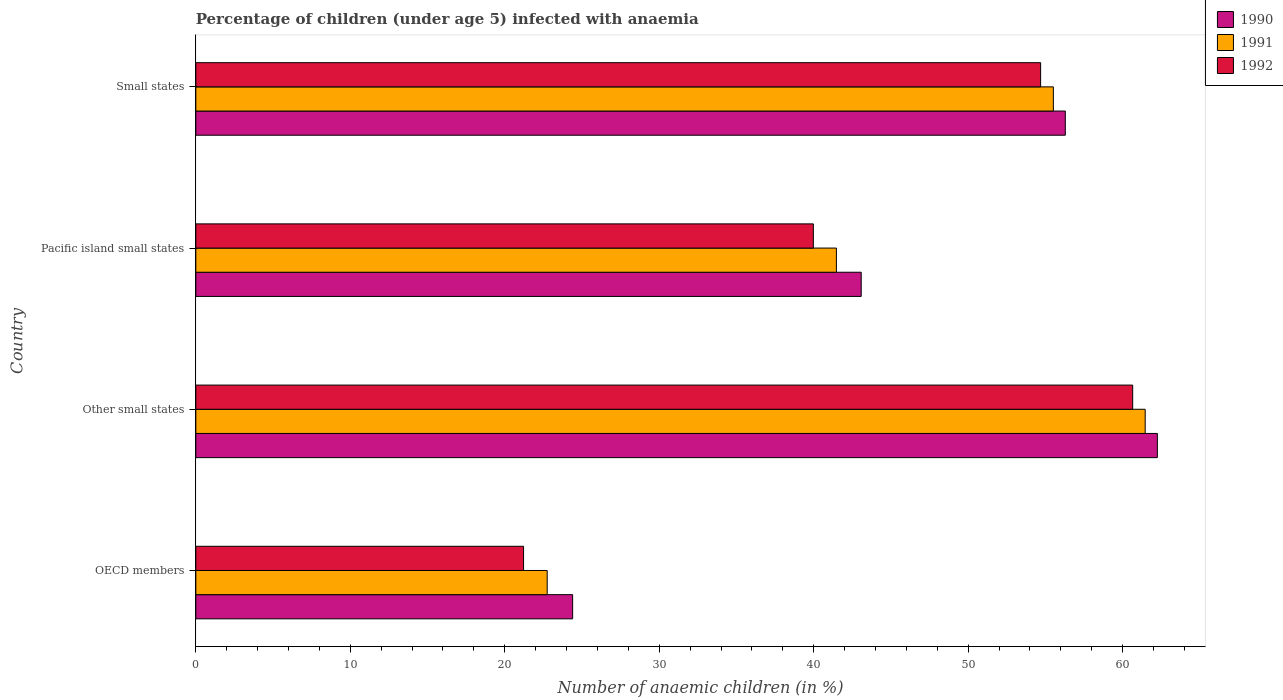How many different coloured bars are there?
Give a very brief answer. 3. Are the number of bars per tick equal to the number of legend labels?
Offer a terse response. Yes. How many bars are there on the 3rd tick from the top?
Your answer should be compact. 3. How many bars are there on the 1st tick from the bottom?
Offer a terse response. 3. What is the label of the 3rd group of bars from the top?
Ensure brevity in your answer.  Other small states. In how many cases, is the number of bars for a given country not equal to the number of legend labels?
Your response must be concise. 0. What is the percentage of children infected with anaemia in in 1991 in OECD members?
Offer a very short reply. 22.75. Across all countries, what is the maximum percentage of children infected with anaemia in in 1991?
Make the answer very short. 61.46. Across all countries, what is the minimum percentage of children infected with anaemia in in 1990?
Offer a very short reply. 24.39. In which country was the percentage of children infected with anaemia in in 1992 maximum?
Give a very brief answer. Other small states. What is the total percentage of children infected with anaemia in in 1991 in the graph?
Provide a short and direct response. 181.18. What is the difference between the percentage of children infected with anaemia in in 1990 in OECD members and that in Other small states?
Make the answer very short. -37.85. What is the difference between the percentage of children infected with anaemia in in 1991 in Pacific island small states and the percentage of children infected with anaemia in in 1992 in Small states?
Keep it short and to the point. -13.22. What is the average percentage of children infected with anaemia in in 1992 per country?
Provide a succinct answer. 44.13. What is the difference between the percentage of children infected with anaemia in in 1991 and percentage of children infected with anaemia in in 1990 in Pacific island small states?
Ensure brevity in your answer.  -1.61. In how many countries, is the percentage of children infected with anaemia in in 1992 greater than 40 %?
Make the answer very short. 2. What is the ratio of the percentage of children infected with anaemia in in 1992 in OECD members to that in Small states?
Give a very brief answer. 0.39. Is the percentage of children infected with anaemia in in 1991 in OECD members less than that in Pacific island small states?
Offer a terse response. Yes. What is the difference between the highest and the second highest percentage of children infected with anaemia in in 1990?
Give a very brief answer. 5.96. What is the difference between the highest and the lowest percentage of children infected with anaemia in in 1991?
Make the answer very short. 38.71. Is it the case that in every country, the sum of the percentage of children infected with anaemia in in 1991 and percentage of children infected with anaemia in in 1990 is greater than the percentage of children infected with anaemia in in 1992?
Your answer should be very brief. Yes. How many bars are there?
Offer a very short reply. 12. How many countries are there in the graph?
Give a very brief answer. 4. What is the difference between two consecutive major ticks on the X-axis?
Keep it short and to the point. 10. Does the graph contain any zero values?
Ensure brevity in your answer.  No. Does the graph contain grids?
Your response must be concise. No. How are the legend labels stacked?
Give a very brief answer. Vertical. What is the title of the graph?
Your answer should be very brief. Percentage of children (under age 5) infected with anaemia. What is the label or title of the X-axis?
Give a very brief answer. Number of anaemic children (in %). What is the Number of anaemic children (in %) of 1990 in OECD members?
Offer a terse response. 24.39. What is the Number of anaemic children (in %) in 1991 in OECD members?
Offer a terse response. 22.75. What is the Number of anaemic children (in %) in 1992 in OECD members?
Make the answer very short. 21.22. What is the Number of anaemic children (in %) of 1990 in Other small states?
Your answer should be compact. 62.25. What is the Number of anaemic children (in %) in 1991 in Other small states?
Your answer should be compact. 61.46. What is the Number of anaemic children (in %) in 1992 in Other small states?
Ensure brevity in your answer.  60.65. What is the Number of anaemic children (in %) of 1990 in Pacific island small states?
Give a very brief answer. 43.07. What is the Number of anaemic children (in %) in 1991 in Pacific island small states?
Provide a succinct answer. 41.47. What is the Number of anaemic children (in %) of 1992 in Pacific island small states?
Provide a short and direct response. 39.98. What is the Number of anaemic children (in %) of 1990 in Small states?
Offer a very short reply. 56.29. What is the Number of anaemic children (in %) in 1991 in Small states?
Your response must be concise. 55.51. What is the Number of anaemic children (in %) in 1992 in Small states?
Make the answer very short. 54.69. Across all countries, what is the maximum Number of anaemic children (in %) of 1990?
Offer a very short reply. 62.25. Across all countries, what is the maximum Number of anaemic children (in %) of 1991?
Provide a short and direct response. 61.46. Across all countries, what is the maximum Number of anaemic children (in %) in 1992?
Ensure brevity in your answer.  60.65. Across all countries, what is the minimum Number of anaemic children (in %) in 1990?
Provide a short and direct response. 24.39. Across all countries, what is the minimum Number of anaemic children (in %) in 1991?
Provide a short and direct response. 22.75. Across all countries, what is the minimum Number of anaemic children (in %) in 1992?
Provide a short and direct response. 21.22. What is the total Number of anaemic children (in %) in 1990 in the graph?
Offer a terse response. 186. What is the total Number of anaemic children (in %) in 1991 in the graph?
Keep it short and to the point. 181.18. What is the total Number of anaemic children (in %) of 1992 in the graph?
Offer a very short reply. 176.53. What is the difference between the Number of anaemic children (in %) in 1990 in OECD members and that in Other small states?
Offer a very short reply. -37.85. What is the difference between the Number of anaemic children (in %) in 1991 in OECD members and that in Other small states?
Offer a very short reply. -38.71. What is the difference between the Number of anaemic children (in %) in 1992 in OECD members and that in Other small states?
Offer a terse response. -39.43. What is the difference between the Number of anaemic children (in %) in 1990 in OECD members and that in Pacific island small states?
Make the answer very short. -18.68. What is the difference between the Number of anaemic children (in %) of 1991 in OECD members and that in Pacific island small states?
Provide a succinct answer. -18.72. What is the difference between the Number of anaemic children (in %) in 1992 in OECD members and that in Pacific island small states?
Offer a very short reply. -18.76. What is the difference between the Number of anaemic children (in %) in 1990 in OECD members and that in Small states?
Your response must be concise. -31.89. What is the difference between the Number of anaemic children (in %) of 1991 in OECD members and that in Small states?
Keep it short and to the point. -32.77. What is the difference between the Number of anaemic children (in %) of 1992 in OECD members and that in Small states?
Your response must be concise. -33.47. What is the difference between the Number of anaemic children (in %) of 1990 in Other small states and that in Pacific island small states?
Your response must be concise. 19.17. What is the difference between the Number of anaemic children (in %) in 1991 in Other small states and that in Pacific island small states?
Offer a terse response. 19.99. What is the difference between the Number of anaemic children (in %) in 1992 in Other small states and that in Pacific island small states?
Your response must be concise. 20.67. What is the difference between the Number of anaemic children (in %) in 1990 in Other small states and that in Small states?
Make the answer very short. 5.96. What is the difference between the Number of anaemic children (in %) in 1991 in Other small states and that in Small states?
Provide a short and direct response. 5.94. What is the difference between the Number of anaemic children (in %) in 1992 in Other small states and that in Small states?
Your answer should be compact. 5.96. What is the difference between the Number of anaemic children (in %) of 1990 in Pacific island small states and that in Small states?
Offer a very short reply. -13.21. What is the difference between the Number of anaemic children (in %) in 1991 in Pacific island small states and that in Small states?
Your answer should be compact. -14.05. What is the difference between the Number of anaemic children (in %) of 1992 in Pacific island small states and that in Small states?
Your answer should be very brief. -14.71. What is the difference between the Number of anaemic children (in %) in 1990 in OECD members and the Number of anaemic children (in %) in 1991 in Other small states?
Ensure brevity in your answer.  -37.06. What is the difference between the Number of anaemic children (in %) in 1990 in OECD members and the Number of anaemic children (in %) in 1992 in Other small states?
Make the answer very short. -36.26. What is the difference between the Number of anaemic children (in %) in 1991 in OECD members and the Number of anaemic children (in %) in 1992 in Other small states?
Offer a terse response. -37.9. What is the difference between the Number of anaemic children (in %) in 1990 in OECD members and the Number of anaemic children (in %) in 1991 in Pacific island small states?
Your answer should be compact. -17.07. What is the difference between the Number of anaemic children (in %) of 1990 in OECD members and the Number of anaemic children (in %) of 1992 in Pacific island small states?
Your answer should be compact. -15.58. What is the difference between the Number of anaemic children (in %) of 1991 in OECD members and the Number of anaemic children (in %) of 1992 in Pacific island small states?
Offer a very short reply. -17.23. What is the difference between the Number of anaemic children (in %) of 1990 in OECD members and the Number of anaemic children (in %) of 1991 in Small states?
Provide a succinct answer. -31.12. What is the difference between the Number of anaemic children (in %) of 1990 in OECD members and the Number of anaemic children (in %) of 1992 in Small states?
Make the answer very short. -30.3. What is the difference between the Number of anaemic children (in %) of 1991 in OECD members and the Number of anaemic children (in %) of 1992 in Small states?
Ensure brevity in your answer.  -31.94. What is the difference between the Number of anaemic children (in %) in 1990 in Other small states and the Number of anaemic children (in %) in 1991 in Pacific island small states?
Provide a short and direct response. 20.78. What is the difference between the Number of anaemic children (in %) of 1990 in Other small states and the Number of anaemic children (in %) of 1992 in Pacific island small states?
Your answer should be very brief. 22.27. What is the difference between the Number of anaemic children (in %) in 1991 in Other small states and the Number of anaemic children (in %) in 1992 in Pacific island small states?
Your answer should be compact. 21.48. What is the difference between the Number of anaemic children (in %) in 1990 in Other small states and the Number of anaemic children (in %) in 1991 in Small states?
Your response must be concise. 6.73. What is the difference between the Number of anaemic children (in %) of 1990 in Other small states and the Number of anaemic children (in %) of 1992 in Small states?
Offer a very short reply. 7.56. What is the difference between the Number of anaemic children (in %) in 1991 in Other small states and the Number of anaemic children (in %) in 1992 in Small states?
Provide a succinct answer. 6.77. What is the difference between the Number of anaemic children (in %) of 1990 in Pacific island small states and the Number of anaemic children (in %) of 1991 in Small states?
Keep it short and to the point. -12.44. What is the difference between the Number of anaemic children (in %) in 1990 in Pacific island small states and the Number of anaemic children (in %) in 1992 in Small states?
Offer a very short reply. -11.61. What is the difference between the Number of anaemic children (in %) of 1991 in Pacific island small states and the Number of anaemic children (in %) of 1992 in Small states?
Provide a short and direct response. -13.22. What is the average Number of anaemic children (in %) in 1990 per country?
Ensure brevity in your answer.  46.5. What is the average Number of anaemic children (in %) of 1991 per country?
Your answer should be very brief. 45.3. What is the average Number of anaemic children (in %) in 1992 per country?
Ensure brevity in your answer.  44.13. What is the difference between the Number of anaemic children (in %) of 1990 and Number of anaemic children (in %) of 1991 in OECD members?
Keep it short and to the point. 1.65. What is the difference between the Number of anaemic children (in %) in 1990 and Number of anaemic children (in %) in 1992 in OECD members?
Make the answer very short. 3.18. What is the difference between the Number of anaemic children (in %) of 1991 and Number of anaemic children (in %) of 1992 in OECD members?
Your response must be concise. 1.53. What is the difference between the Number of anaemic children (in %) of 1990 and Number of anaemic children (in %) of 1991 in Other small states?
Your answer should be compact. 0.79. What is the difference between the Number of anaemic children (in %) of 1990 and Number of anaemic children (in %) of 1992 in Other small states?
Offer a terse response. 1.6. What is the difference between the Number of anaemic children (in %) of 1991 and Number of anaemic children (in %) of 1992 in Other small states?
Keep it short and to the point. 0.81. What is the difference between the Number of anaemic children (in %) of 1990 and Number of anaemic children (in %) of 1991 in Pacific island small states?
Offer a very short reply. 1.61. What is the difference between the Number of anaemic children (in %) of 1990 and Number of anaemic children (in %) of 1992 in Pacific island small states?
Offer a terse response. 3.1. What is the difference between the Number of anaemic children (in %) of 1991 and Number of anaemic children (in %) of 1992 in Pacific island small states?
Make the answer very short. 1.49. What is the difference between the Number of anaemic children (in %) of 1990 and Number of anaemic children (in %) of 1991 in Small states?
Provide a succinct answer. 0.77. What is the difference between the Number of anaemic children (in %) of 1990 and Number of anaemic children (in %) of 1992 in Small states?
Your answer should be very brief. 1.6. What is the difference between the Number of anaemic children (in %) in 1991 and Number of anaemic children (in %) in 1992 in Small states?
Your answer should be compact. 0.82. What is the ratio of the Number of anaemic children (in %) in 1990 in OECD members to that in Other small states?
Give a very brief answer. 0.39. What is the ratio of the Number of anaemic children (in %) in 1991 in OECD members to that in Other small states?
Provide a succinct answer. 0.37. What is the ratio of the Number of anaemic children (in %) in 1992 in OECD members to that in Other small states?
Ensure brevity in your answer.  0.35. What is the ratio of the Number of anaemic children (in %) of 1990 in OECD members to that in Pacific island small states?
Offer a very short reply. 0.57. What is the ratio of the Number of anaemic children (in %) of 1991 in OECD members to that in Pacific island small states?
Provide a short and direct response. 0.55. What is the ratio of the Number of anaemic children (in %) in 1992 in OECD members to that in Pacific island small states?
Make the answer very short. 0.53. What is the ratio of the Number of anaemic children (in %) of 1990 in OECD members to that in Small states?
Your response must be concise. 0.43. What is the ratio of the Number of anaemic children (in %) of 1991 in OECD members to that in Small states?
Your response must be concise. 0.41. What is the ratio of the Number of anaemic children (in %) in 1992 in OECD members to that in Small states?
Ensure brevity in your answer.  0.39. What is the ratio of the Number of anaemic children (in %) in 1990 in Other small states to that in Pacific island small states?
Provide a succinct answer. 1.45. What is the ratio of the Number of anaemic children (in %) in 1991 in Other small states to that in Pacific island small states?
Offer a very short reply. 1.48. What is the ratio of the Number of anaemic children (in %) of 1992 in Other small states to that in Pacific island small states?
Offer a terse response. 1.52. What is the ratio of the Number of anaemic children (in %) in 1990 in Other small states to that in Small states?
Offer a terse response. 1.11. What is the ratio of the Number of anaemic children (in %) of 1991 in Other small states to that in Small states?
Ensure brevity in your answer.  1.11. What is the ratio of the Number of anaemic children (in %) in 1992 in Other small states to that in Small states?
Provide a succinct answer. 1.11. What is the ratio of the Number of anaemic children (in %) in 1990 in Pacific island small states to that in Small states?
Give a very brief answer. 0.77. What is the ratio of the Number of anaemic children (in %) of 1991 in Pacific island small states to that in Small states?
Make the answer very short. 0.75. What is the ratio of the Number of anaemic children (in %) in 1992 in Pacific island small states to that in Small states?
Keep it short and to the point. 0.73. What is the difference between the highest and the second highest Number of anaemic children (in %) of 1990?
Give a very brief answer. 5.96. What is the difference between the highest and the second highest Number of anaemic children (in %) in 1991?
Keep it short and to the point. 5.94. What is the difference between the highest and the second highest Number of anaemic children (in %) of 1992?
Your answer should be very brief. 5.96. What is the difference between the highest and the lowest Number of anaemic children (in %) in 1990?
Your answer should be compact. 37.85. What is the difference between the highest and the lowest Number of anaemic children (in %) in 1991?
Offer a very short reply. 38.71. What is the difference between the highest and the lowest Number of anaemic children (in %) in 1992?
Provide a short and direct response. 39.43. 